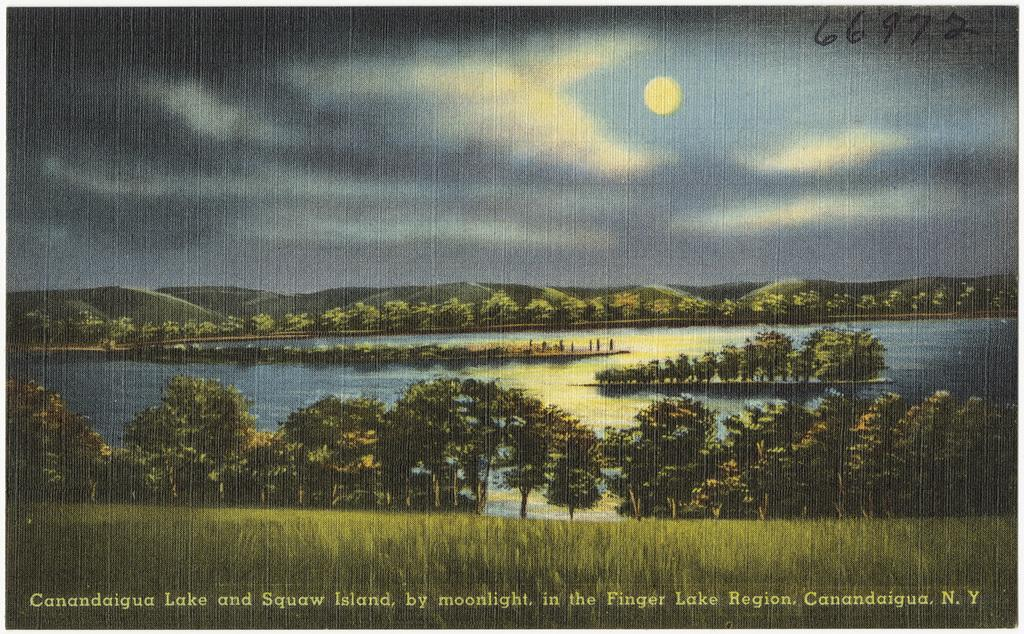What type of landscape is depicted in the painting? The painting contains many trees, hills, grass, water, and a cloudy sky. Can you describe the sky in the painting? The sky in the painting is cloudy. What celestial body is visible in the painting? The painting contains a moon. What type of terrain is present in the painting? The painting contains hills and grass. How many buns are present in the painting? There are no buns present in the painting; it depicts a landscape with trees, hills, grass, water, and a cloudy sky. 